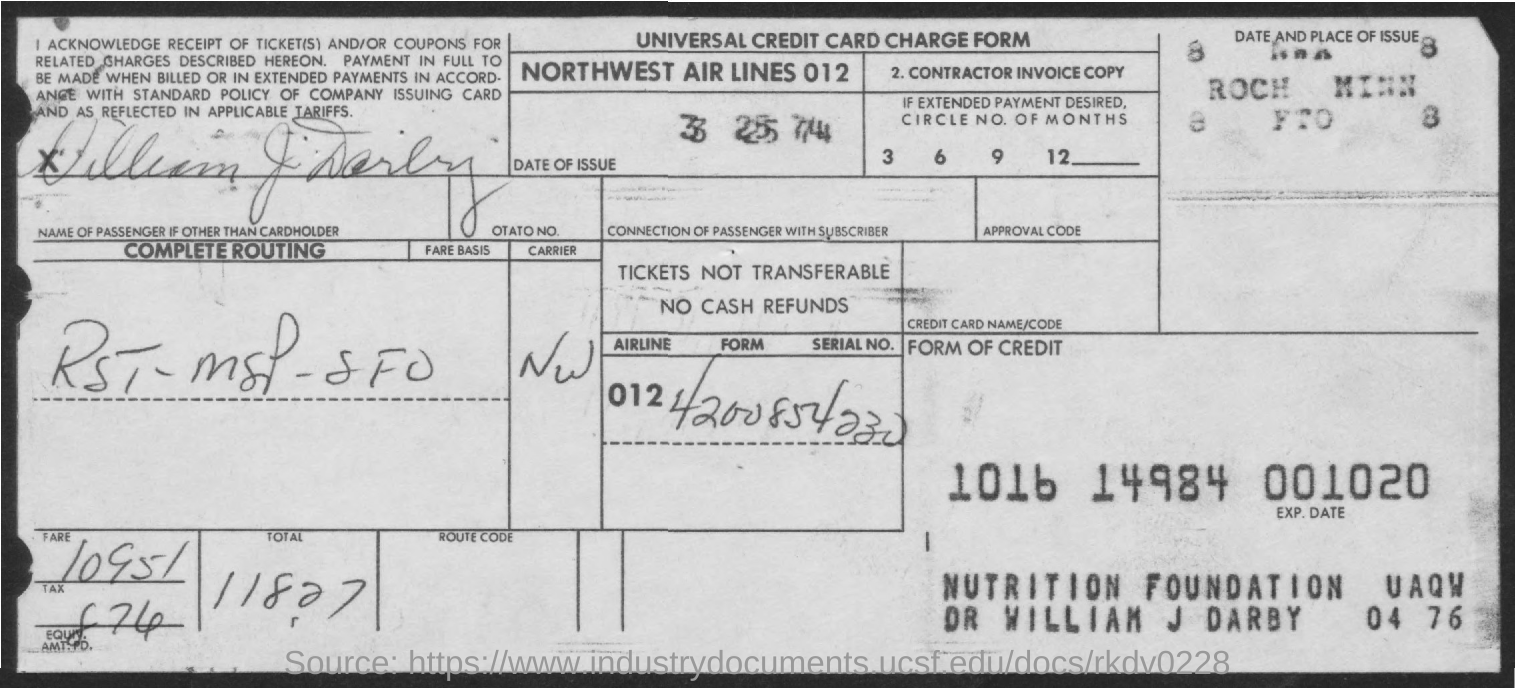Point out several critical features in this image. The date of issue as provided on the form is March 25, 1974. This is a declaration that the form in question is a Universal Credit Card Charge form. 